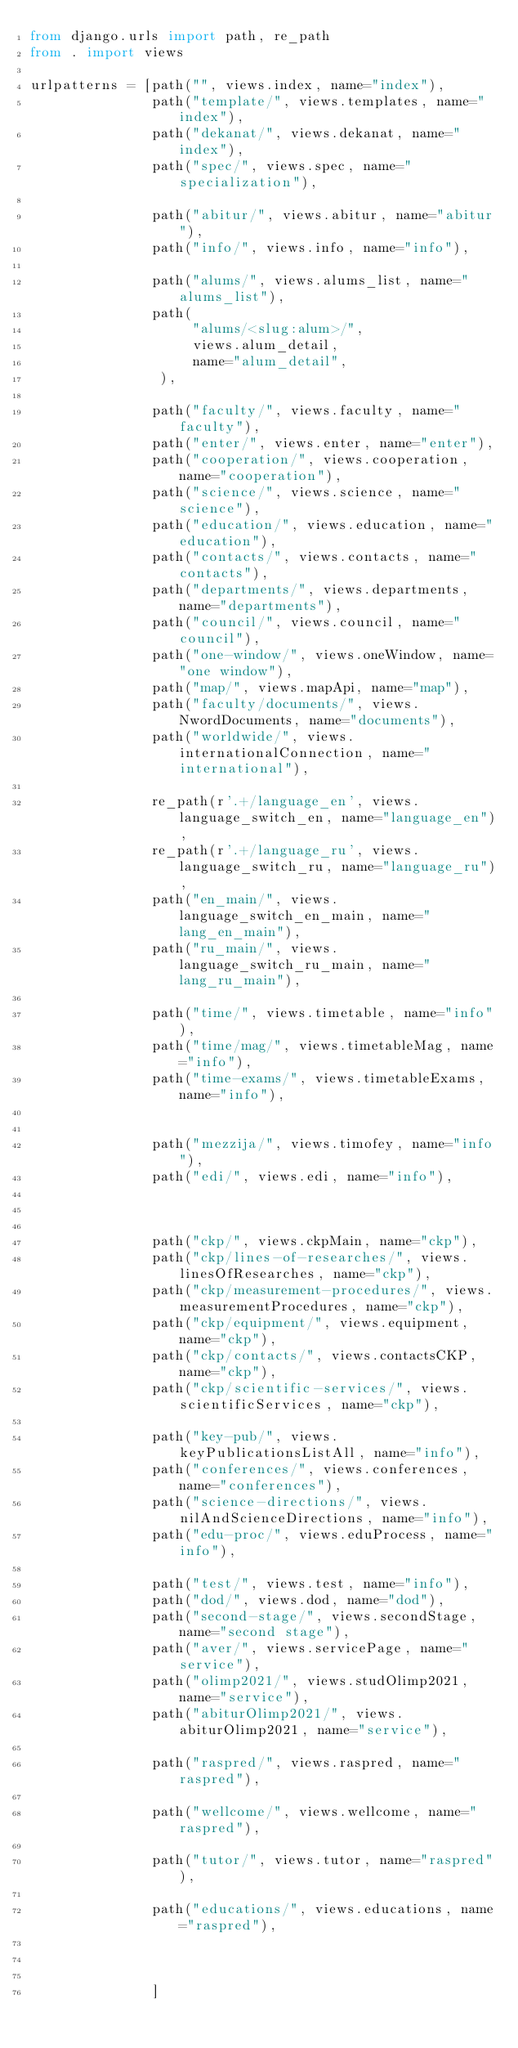<code> <loc_0><loc_0><loc_500><loc_500><_Python_>from django.urls import path, re_path
from . import views

urlpatterns = [path("", views.index, name="index"),
               path("template/", views.templates, name="index"),
               path("dekanat/", views.dekanat, name="index"),
               path("spec/", views.spec, name="specialization"),

               path("abitur/", views.abitur, name="abitur"),
               path("info/", views.info, name="info"),

               path("alums/", views.alums_list, name="alums_list"),
               path(
                    "alums/<slug:alum>/",
                    views.alum_detail,
                    name="alum_detail",
                ),

               path("faculty/", views.faculty, name="faculty"),
               path("enter/", views.enter, name="enter"),
               path("cooperation/", views.cooperation, name="cooperation"),
               path("science/", views.science, name="science"),
               path("education/", views.education, name="education"),
               path("contacts/", views.contacts, name="contacts"),
               path("departments/", views.departments, name="departments"),
               path("council/", views.council, name="council"),
               path("one-window/", views.oneWindow, name="one window"),
               path("map/", views.mapApi, name="map"),
               path("faculty/documents/", views.NwordDocuments, name="documents"),
               path("worldwide/", views.internationalConnection, name="international"),

               re_path(r'.+/language_en', views.language_switch_en, name="language_en"),
               re_path(r'.+/language_ru', views.language_switch_ru, name="language_ru"),
               path("en_main/", views.language_switch_en_main, name="lang_en_main"),
               path("ru_main/", views.language_switch_ru_main, name="lang_ru_main"),

               path("time/", views.timetable, name="info"),
               path("time/mag/", views.timetableMag, name="info"),
               path("time-exams/", views.timetableExams, name="info"),


               path("mezzija/", views.timofey, name="info"),
               path("edi/", views.edi, name="info"),



               path("ckp/", views.ckpMain, name="ckp"),
               path("ckp/lines-of-researches/", views.linesOfResearches, name="ckp"),
               path("ckp/measurement-procedures/", views.measurementProcedures, name="ckp"),
               path("ckp/equipment/", views.equipment, name="ckp"),
               path("ckp/contacts/", views.contactsCKP, name="ckp"),
               path("ckp/scientific-services/", views.scientificServices, name="ckp"),

               path("key-pub/", views.keyPublicationsListAll, name="info"),
               path("conferences/", views.conferences, name="conferences"),
               path("science-directions/", views.nilAndScienceDirections, name="info"),
               path("edu-proc/", views.eduProcess, name="info"),

               path("test/", views.test, name="info"),
               path("dod/", views.dod, name="dod"),
               path("second-stage/", views.secondStage, name="second stage"),
               path("aver/", views.servicePage, name="service"),
               path("olimp2021/", views.studOlimp2021, name="service"),
               path("abiturOlimp2021/", views.abiturOlimp2021, name="service"),

               path("raspred/", views.raspred, name="raspred"),

               path("wellcome/", views.wellcome, name="raspred"),

               path("tutor/", views.tutor, name="raspred"),

               path("educations/", views.educations, name="raspred"),



               ]
</code> 